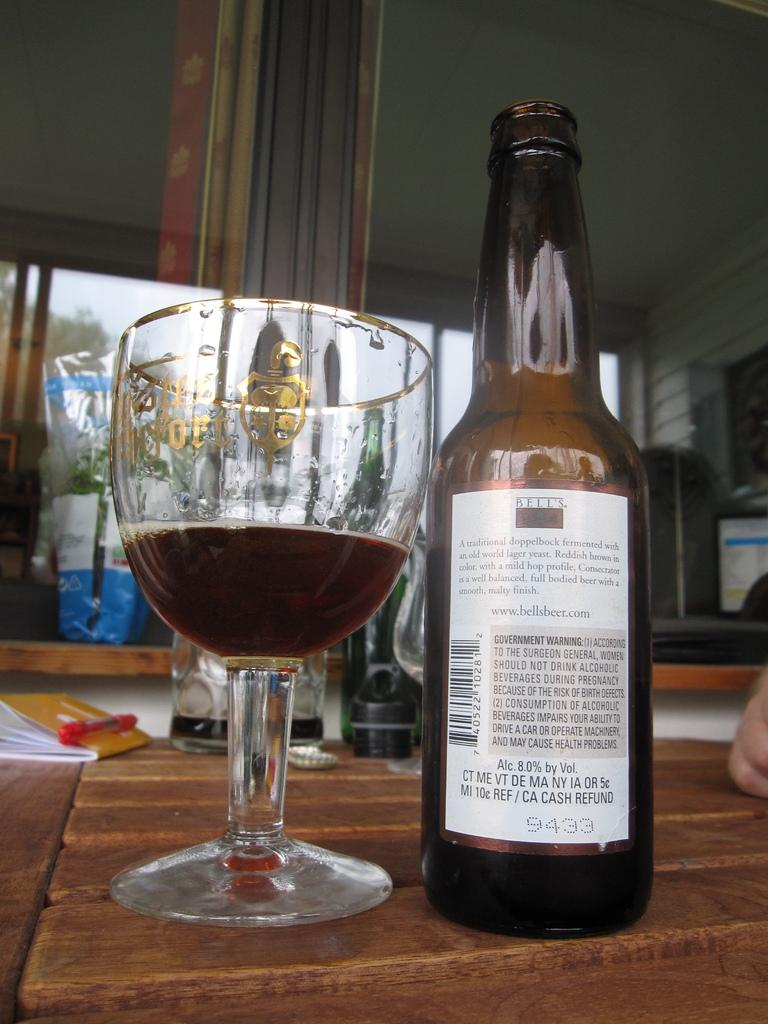What type of beverage container is present in the image? There is a wine bottle in the image. What is the wine bottle paired with in the image? There is a wine glass in the image. What is inside the wine glass? The wine glass contains wine. What type of pest can be seen crawling on the wine bottle in the image? There are no pests visible on the wine bottle in the image. 